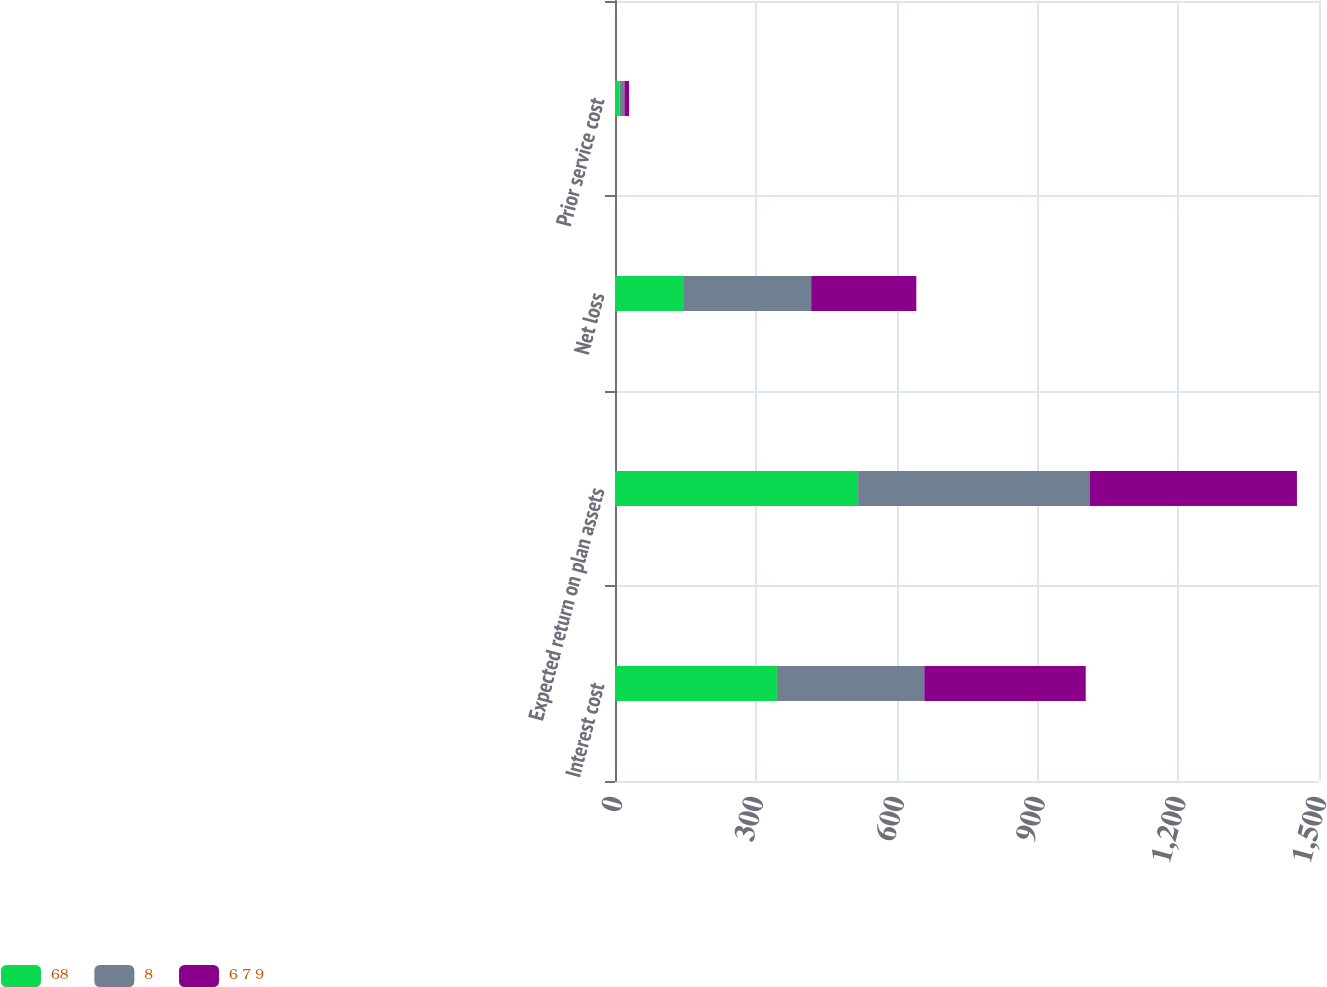Convert chart. <chart><loc_0><loc_0><loc_500><loc_500><stacked_bar_chart><ecel><fcel>Interest cost<fcel>Expected return on plan assets<fcel>Net loss<fcel>Prior service cost<nl><fcel>68<fcel>345<fcel>518<fcel>147<fcel>10<nl><fcel>8<fcel>314<fcel>493<fcel>271<fcel>10<nl><fcel>6 7 9<fcel>344<fcel>442<fcel>224<fcel>10<nl></chart> 